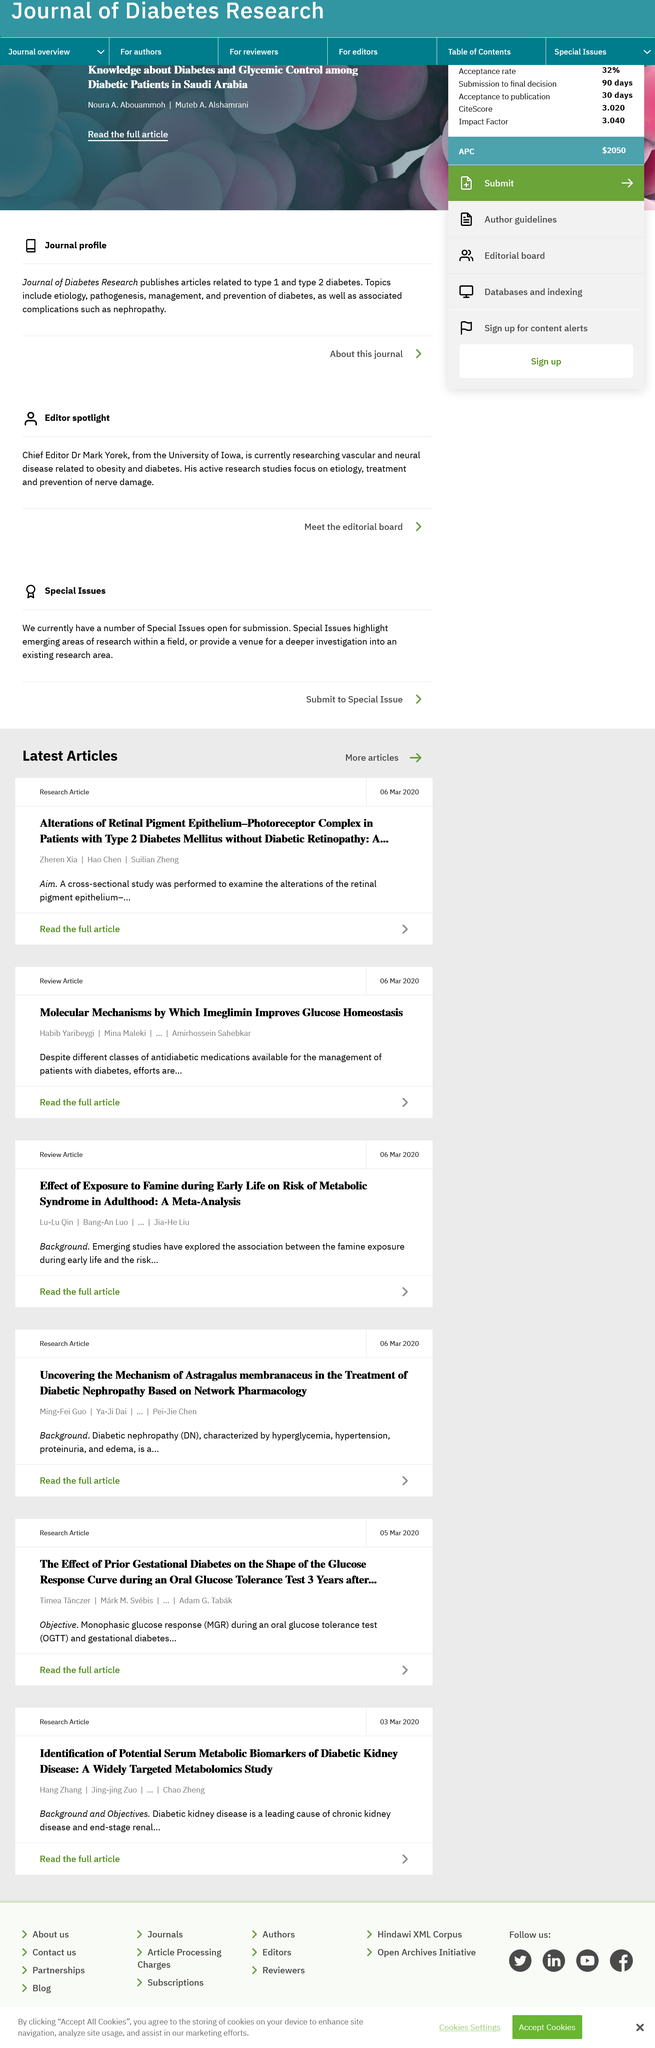Point out several critical features in this image. Habib Yaribeygi participated in writing the article "Molecular Mechanisms by which Imeglimin improves glucose homeostasis. Mina Maleki did not participate in the article titled "Alterations of Retinal Pigment Epithelium. Three individuals, Zheren Xia, Hao Chen, and Suilian Zheng, participated in the article titled "Alterations of Retinal Pigment Epithelium. 